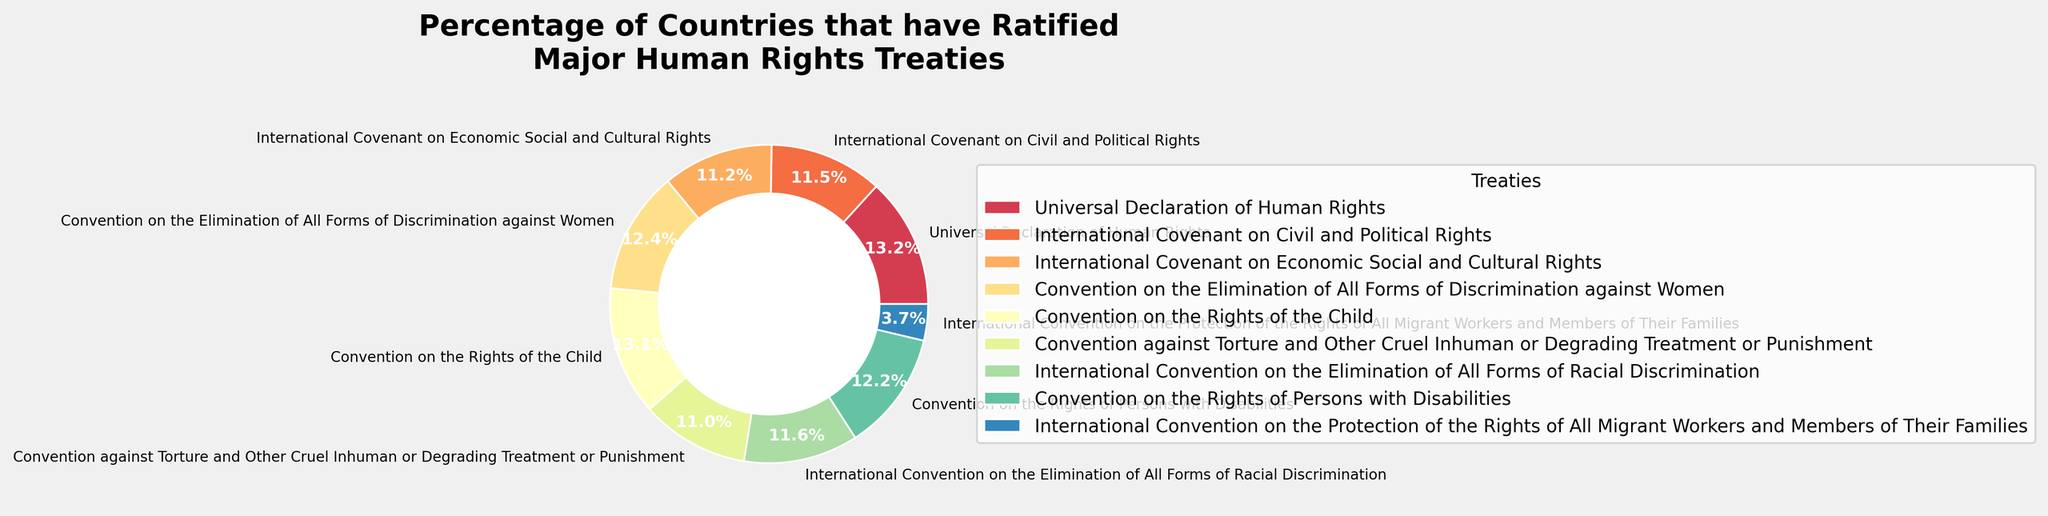Which treaty has the highest percentage of ratification? The figure shows the percentage of countries that have ratified each major human rights treaty. The Universal Declaration of Human Rights has a ratification percentage of 100%, which is the highest.
Answer: Universal Declaration of Human Rights Which treaty has the lowest percentage of ratification? By examining the figure, it is evident that the International Convention on the Protection of the Rights of All Migrant Workers and Members of Their Families has the lowest ratification percentage at 28%.
Answer: International Convention on the Protection of the Rights of All Migrant Workers and Members of Their Families What is the difference in ratification percentages between the Convention on the Rights of the Child and the International Convention on the Protection of the Rights of All Migrant Workers and Members of Their Families? The ratification percentage of the Convention on the Rights of the Child is 99%, and the ratification percentage of the International Convention on the Protection of the Rights of All Migrant Workers and Members of Their Families is 28%. The difference is 99% - 28% = 71%.
Answer: 71% What is the average ratification percentage of all the treaties combined? The percentages are 100, 87, 85, 94, 99, 83, 88, 92, and 28. Sum them up: 100 + 87 + 85 + 94 + 99 + 83 + 88 + 92 + 28 = 756. There are 9 treaties, so the average is 756 / 9 = 84.
Answer: 84 Does the Convention on the Elimination of All Forms of Discrimination against Women have a higher ratification percentage than the International Covenant on Civil and Political Rights? The Convention on the Elimination of All Forms of Discrimination against Women has a ratification percentage of 94%, while the International Covenant on Civil and Political Rights has a ratification percentage of 87%. Therefore, 94% is greater than 87%.
Answer: Yes How many more countries have ratified the International Covenant on Civil and Political Rights compared to the International Convention on the Elimination of All Forms of Racial Discrimination? The International Covenant on Civil and Political Rights has a ratification percentage of 87%, and the International Convention on the Elimination of All Forms of Racial Discrimination has a ratification percentage of 88%. Therefore, 88% is 1% greater than 87%.
Answer: 1% What is the total percentage of countries that have ratified both the International Covenant on Economic Social and Cultural Rights and the Convention against Torture? The percentage for the International Covenant on Economic Social and Cultural Rights is 85%, and for the Convention against Torture is 83%. The total is 85% + 83% = 168%.
Answer: 168% Which treaty has a darker color corresponding to its section in the pie chart: the International Covenant on Economic Social and Cultural Rights or the Convention on the Rights of the Child? The visual representation in the figure can show which section has a darker color based on the pie chart's coloration. Typically, the Convention on the Rights of the Child might have a noticeably distinguished darker or lighter color compared to others.
Answer: Convention on the Rights of the Child (assuming from typical visualization) Is the ratification percentage of the Convention on the Rights of Persons with Disabilities more than twice that of the International Convention on the Protection of the Rights of All Migrant Workers and Members of Their Families? The ratification percentage of the Convention on the Rights of Persons with Disabilities is 92%, and the ratification percentage of the International Convention on the Protection of the Rights of All Migrant Workers and Members of Their Families is 28%. Twice 28% is 56%, and 92% is greater than 56%.
Answer: Yes 